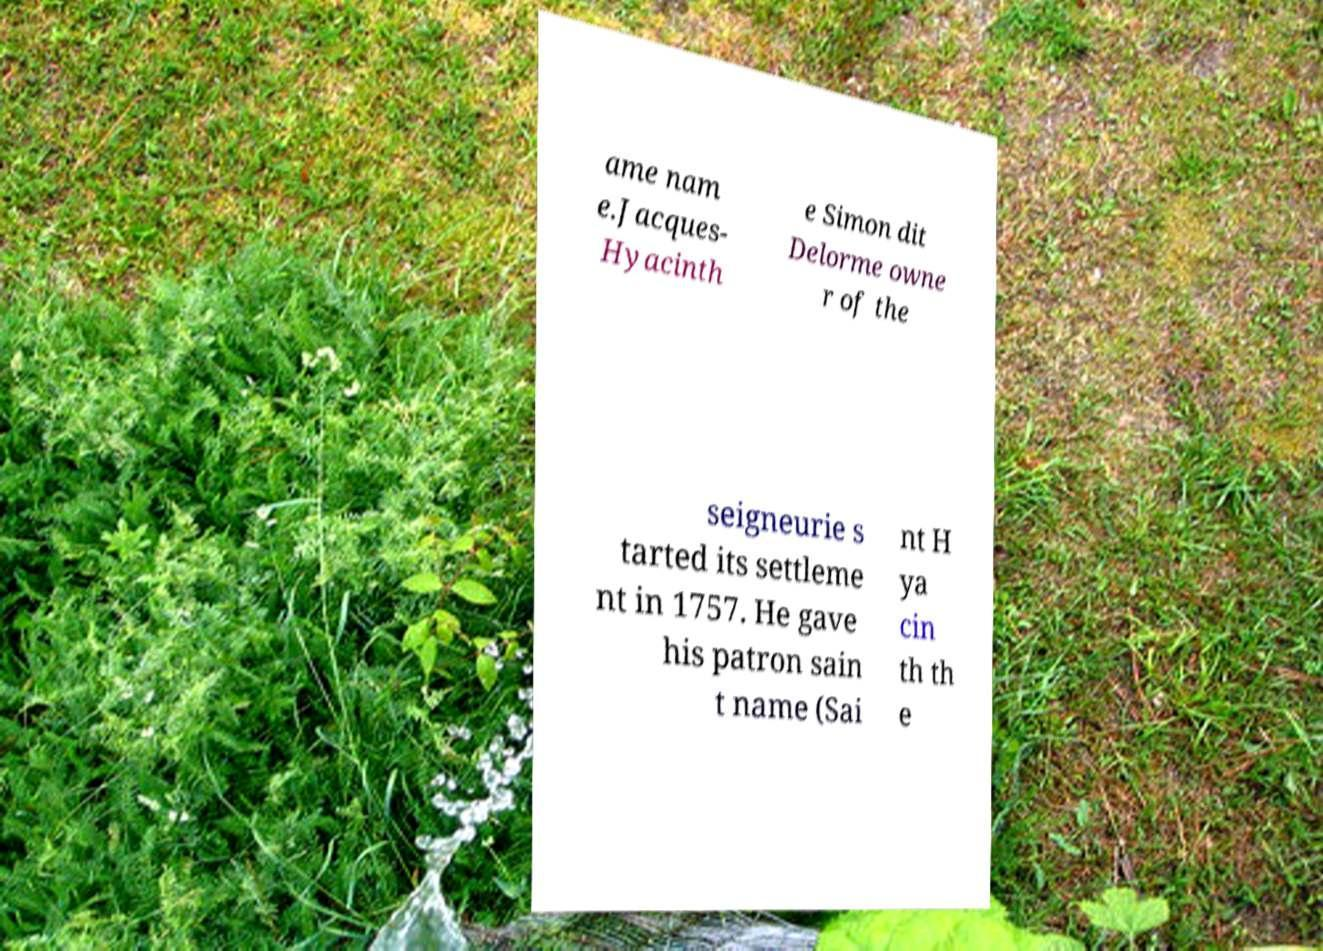Please read and relay the text visible in this image. What does it say? ame nam e.Jacques- Hyacinth e Simon dit Delorme owne r of the seigneurie s tarted its settleme nt in 1757. He gave his patron sain t name (Sai nt H ya cin th th e 